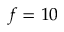<formula> <loc_0><loc_0><loc_500><loc_500>f = 1 0</formula> 